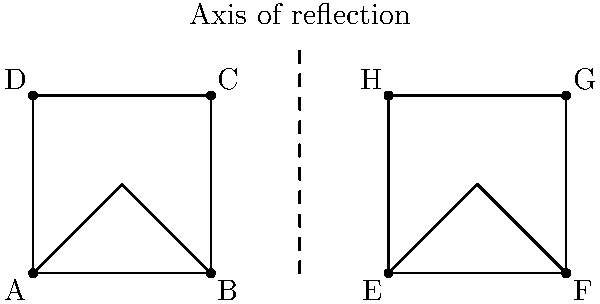You're designing a new knitting pattern and want to create a symmetric design. The left half of your pattern is represented by the square ABCD, with a diagonal line from A to B. If you reflect this pattern across the vertical axis shown, what will be the coordinates of point G in the reflected pattern? To find the coordinates of point G after reflection, let's follow these steps:

1) First, identify the original point that G is reflecting from. In this case, it's point C with coordinates (2,2).

2) The axis of reflection is a vertical line that appears to be at x = 3.

3) To reflect a point across a vertical line, we keep the y-coordinate the same and change the x-coordinate. The new x-coordinate will be as far to the right of the axis as the original point was to the left.

4) To calculate this:
   - Distance from C to the axis: 3 - 2 = 1
   - New x-coordinate: 3 + 1 = 4

5) Therefore, point G will have:
   - x-coordinate: 4
   - y-coordinate: 2 (unchanged from C)

So, the coordinates of point G after reflection will be (4,2).
Answer: (4,2) 